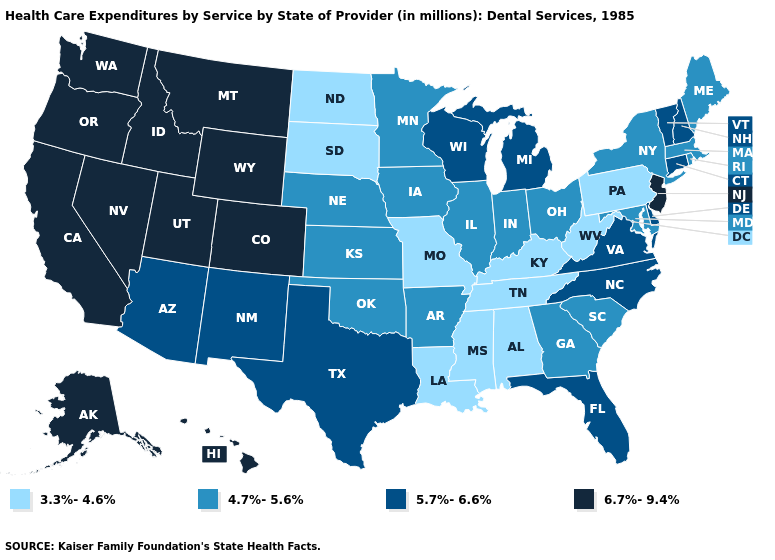Name the states that have a value in the range 6.7%-9.4%?
Short answer required. Alaska, California, Colorado, Hawaii, Idaho, Montana, Nevada, New Jersey, Oregon, Utah, Washington, Wyoming. Name the states that have a value in the range 3.3%-4.6%?
Write a very short answer. Alabama, Kentucky, Louisiana, Mississippi, Missouri, North Dakota, Pennsylvania, South Dakota, Tennessee, West Virginia. Which states have the highest value in the USA?
Short answer required. Alaska, California, Colorado, Hawaii, Idaho, Montana, Nevada, New Jersey, Oregon, Utah, Washington, Wyoming. What is the value of Pennsylvania?
Concise answer only. 3.3%-4.6%. What is the value of Nebraska?
Answer briefly. 4.7%-5.6%. Among the states that border North Dakota , which have the highest value?
Short answer required. Montana. Name the states that have a value in the range 6.7%-9.4%?
Give a very brief answer. Alaska, California, Colorado, Hawaii, Idaho, Montana, Nevada, New Jersey, Oregon, Utah, Washington, Wyoming. What is the value of Arkansas?
Write a very short answer. 4.7%-5.6%. What is the value of Vermont?
Keep it brief. 5.7%-6.6%. Does Connecticut have a higher value than South Dakota?
Give a very brief answer. Yes. Among the states that border New Hampshire , which have the highest value?
Write a very short answer. Vermont. What is the lowest value in states that border Colorado?
Short answer required. 4.7%-5.6%. Does Utah have the highest value in the USA?
Write a very short answer. Yes. What is the lowest value in the West?
Quick response, please. 5.7%-6.6%. 